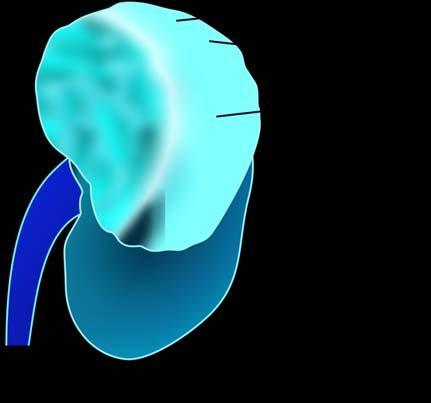what has reniform contour?
Answer the question using a single word or phrase. Rest of the kidney 